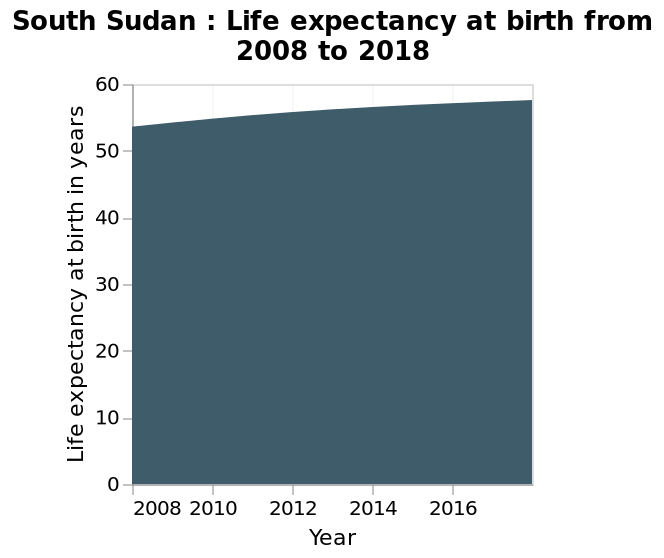<image>
What is the title of the area chart? South Sudan : Life expectancy at birth from 2008 to 2018. 